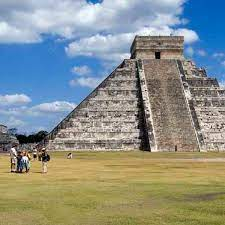What activities do tourists engage in around this pyramid? Tourists around the Chichen Itza pyramid typically engage in a variety of activities. Many are seen taking photographs to capture the stunning architecture and the scenic surroundings. Guided tours are common, with tour guides explaining the history, significance, and the scientific and astronomical wonders of the structure. Some tourists also enjoy exploring the surrounding archaeological sites, visiting nearby Cenotes (natural sinkholes), and participating in local cultural events and rituals. Souvenirs and refreshments are often available from vendors in the vicinity, adding to the full experience. 